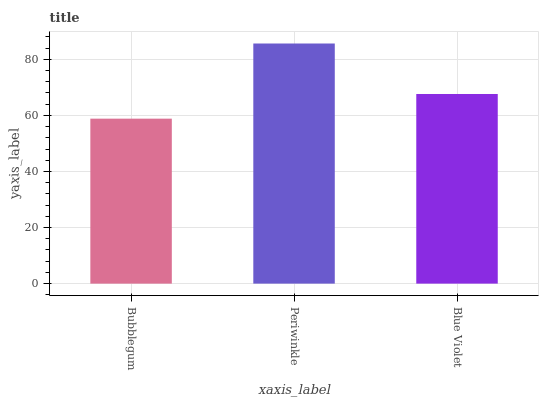Is Bubblegum the minimum?
Answer yes or no. Yes. Is Periwinkle the maximum?
Answer yes or no. Yes. Is Blue Violet the minimum?
Answer yes or no. No. Is Blue Violet the maximum?
Answer yes or no. No. Is Periwinkle greater than Blue Violet?
Answer yes or no. Yes. Is Blue Violet less than Periwinkle?
Answer yes or no. Yes. Is Blue Violet greater than Periwinkle?
Answer yes or no. No. Is Periwinkle less than Blue Violet?
Answer yes or no. No. Is Blue Violet the high median?
Answer yes or no. Yes. Is Blue Violet the low median?
Answer yes or no. Yes. Is Periwinkle the high median?
Answer yes or no. No. Is Bubblegum the low median?
Answer yes or no. No. 